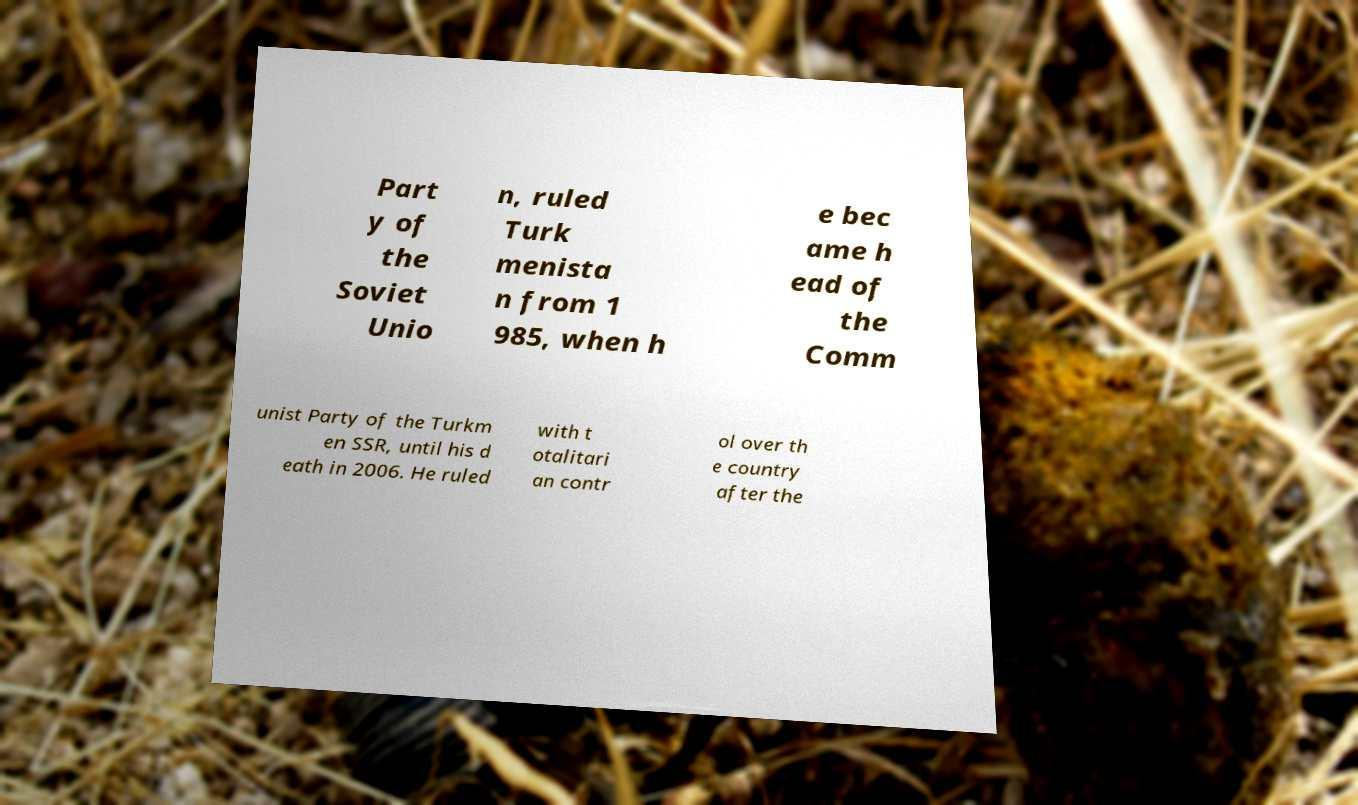I need the written content from this picture converted into text. Can you do that? Part y of the Soviet Unio n, ruled Turk menista n from 1 985, when h e bec ame h ead of the Comm unist Party of the Turkm en SSR, until his d eath in 2006. He ruled with t otalitari an contr ol over th e country after the 